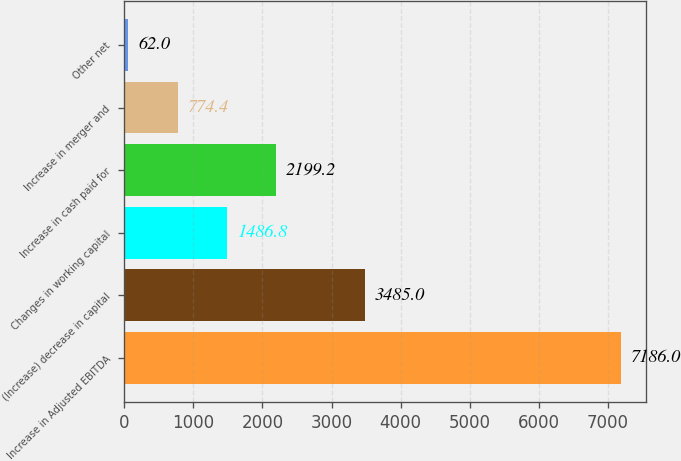<chart> <loc_0><loc_0><loc_500><loc_500><bar_chart><fcel>Increase in Adjusted EBITDA<fcel>(Increase) decrease in capital<fcel>Changes in working capital<fcel>Increase in cash paid for<fcel>Increase in merger and<fcel>Other net<nl><fcel>7186<fcel>3485<fcel>1486.8<fcel>2199.2<fcel>774.4<fcel>62<nl></chart> 